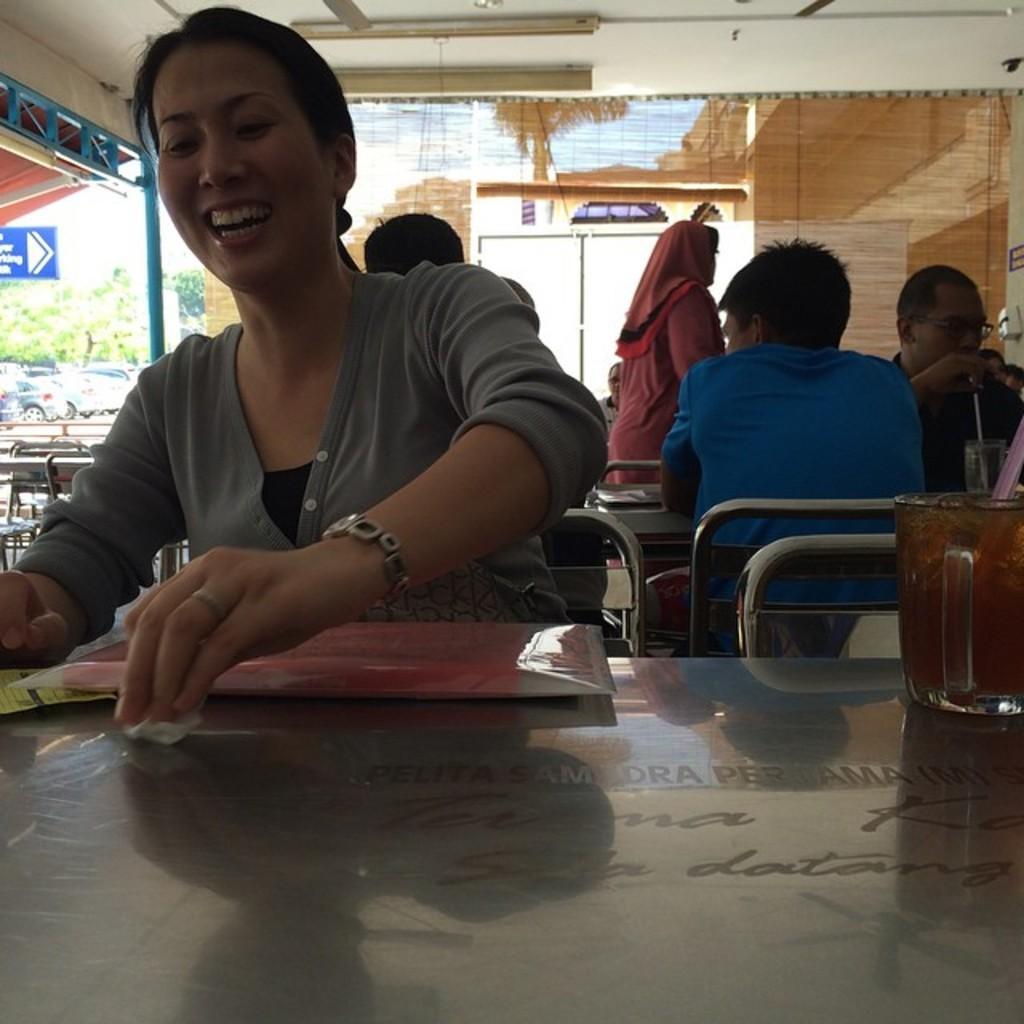Could you give a brief overview of what you see in this image? In the image we can see there are people who are sitting on chair and in front of them there is a table on which there is a juice glass kept. 